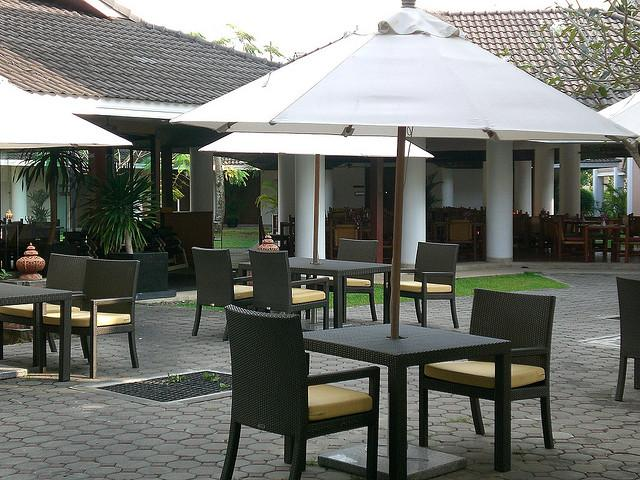What is the purpose of the umbrellas? Please explain your reasoning. sun protection. The outdoors are sunny. 